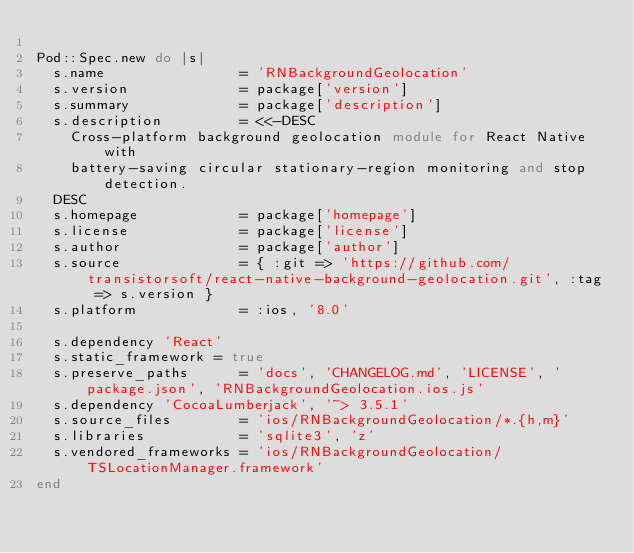Convert code to text. <code><loc_0><loc_0><loc_500><loc_500><_Ruby_>
Pod::Spec.new do |s|
  s.name                = 'RNBackgroundGeolocation'
  s.version             = package['version']
  s.summary             = package['description']
  s.description         = <<-DESC
    Cross-platform background geolocation module for React Native with
    battery-saving circular stationary-region monitoring and stop detection.
  DESC
  s.homepage            = package['homepage']
  s.license             = package['license']
  s.author              = package['author']
  s.source              = { :git => 'https://github.com/transistorsoft/react-native-background-geolocation.git', :tag => s.version }
  s.platform            = :ios, '8.0'

  s.dependency 'React'
  s.static_framework = true
  s.preserve_paths      = 'docs', 'CHANGELOG.md', 'LICENSE', 'package.json', 'RNBackgroundGeolocation.ios.js'
  s.dependency 'CocoaLumberjack', '~> 3.5.1'
  s.source_files        = 'ios/RNBackgroundGeolocation/*.{h,m}'
  s.libraries           = 'sqlite3', 'z'
  s.vendored_frameworks = 'ios/RNBackgroundGeolocation/TSLocationManager.framework'
end
</code> 